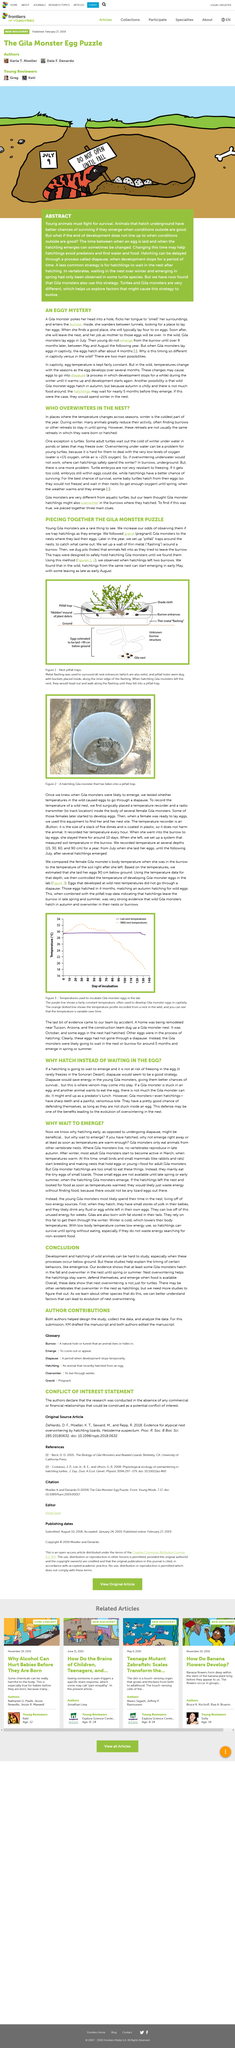Outline some significant characteristics in this image. The title of the article is "Why Wait to Emerge?" The article is about Gila monsters, a type of reptile that is native to the southwestern United States and northern Mexico. To increase the likelihood of observing young Gila monsters, the best approach is to trap hatchlings as they emerge from their eggs, which significantly increases the odds of observing these elusive creatures in their natural habitat. In the wild, Gila hatchlings from the same nest can begin emerging as early as May, with some delaying their emergence until August. The temperature of a wild Gila monster nest was recorded by surgically placing a temperature recorder and a radio transmitter inside the bodies of several female Gila monsters. The females were located using tracking equipment, and the data was gathered when they were ready to lay eggs. 